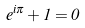Convert formula to latex. <formula><loc_0><loc_0><loc_500><loc_500>e ^ { i \pi } + 1 = 0</formula> 